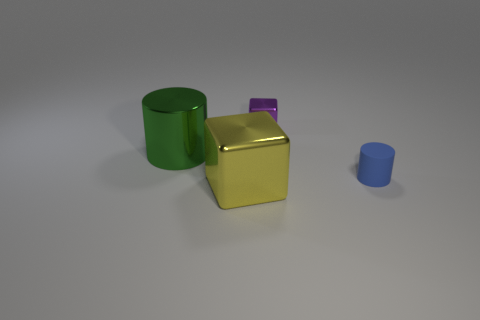Are there any blue cylinders that have the same size as the matte thing?
Ensure brevity in your answer.  No. There is a small thing behind the rubber cylinder; what color is it?
Keep it short and to the point. Purple. There is a cube in front of the tiny purple block; is there a cube in front of it?
Give a very brief answer. No. How many other things are the same color as the small cylinder?
Your answer should be compact. 0. Do the cube in front of the rubber object and the cylinder on the right side of the yellow shiny block have the same size?
Ensure brevity in your answer.  No. There is a rubber object in front of the metallic cube behind the yellow shiny block; how big is it?
Ensure brevity in your answer.  Small. There is a object that is behind the yellow metal block and in front of the large green cylinder; what material is it made of?
Offer a terse response. Rubber. What color is the small metallic thing?
Your answer should be very brief. Purple. Is there anything else that has the same material as the small blue thing?
Ensure brevity in your answer.  No. There is a big metallic object that is to the left of the yellow shiny thing; what is its shape?
Offer a terse response. Cylinder. 